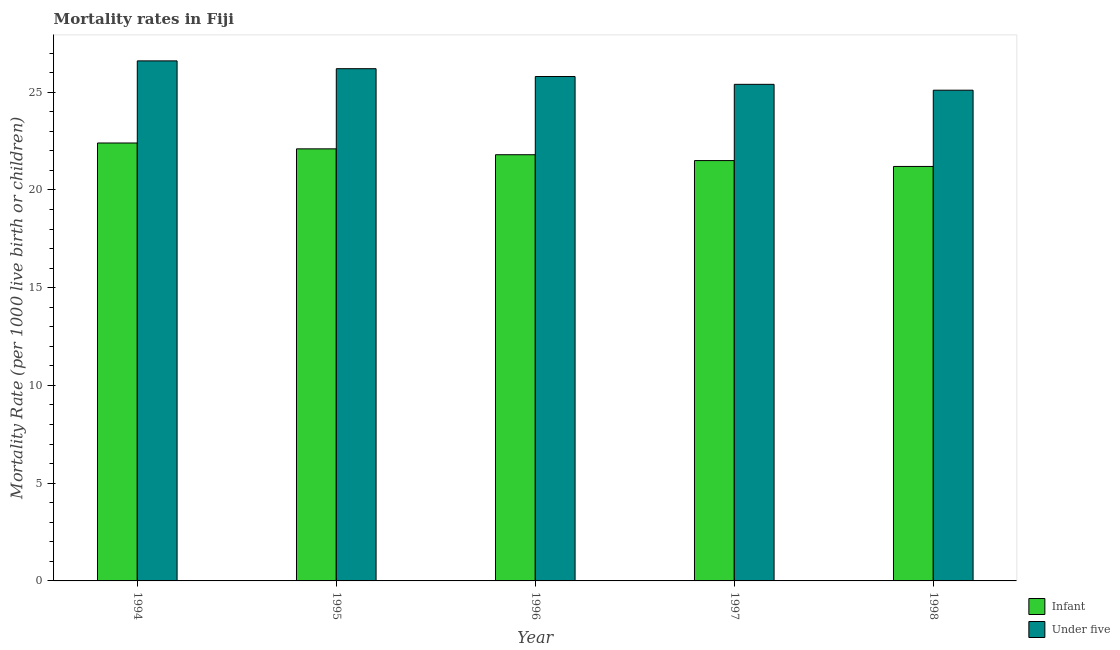How many different coloured bars are there?
Your answer should be compact. 2. Are the number of bars per tick equal to the number of legend labels?
Provide a short and direct response. Yes. How many bars are there on the 3rd tick from the right?
Offer a terse response. 2. In how many cases, is the number of bars for a given year not equal to the number of legend labels?
Your answer should be compact. 0. Across all years, what is the maximum infant mortality rate?
Ensure brevity in your answer.  22.4. Across all years, what is the minimum under-5 mortality rate?
Keep it short and to the point. 25.1. What is the total under-5 mortality rate in the graph?
Provide a short and direct response. 129.1. What is the difference between the infant mortality rate in 1996 and that in 1997?
Your response must be concise. 0.3. What is the difference between the infant mortality rate in 1996 and the under-5 mortality rate in 1997?
Your answer should be very brief. 0.3. What is the average infant mortality rate per year?
Your response must be concise. 21.8. In the year 1994, what is the difference between the under-5 mortality rate and infant mortality rate?
Your answer should be very brief. 0. What is the ratio of the under-5 mortality rate in 1994 to that in 1996?
Offer a terse response. 1.03. Is the under-5 mortality rate in 1994 less than that in 1995?
Give a very brief answer. No. What is the difference between the highest and the second highest under-5 mortality rate?
Your answer should be compact. 0.4. Is the sum of the under-5 mortality rate in 1994 and 1995 greater than the maximum infant mortality rate across all years?
Provide a succinct answer. Yes. What does the 2nd bar from the left in 1995 represents?
Offer a terse response. Under five. What does the 1st bar from the right in 1995 represents?
Give a very brief answer. Under five. How many bars are there?
Ensure brevity in your answer.  10. What is the difference between two consecutive major ticks on the Y-axis?
Ensure brevity in your answer.  5. Where does the legend appear in the graph?
Your answer should be compact. Bottom right. How are the legend labels stacked?
Give a very brief answer. Vertical. What is the title of the graph?
Your answer should be compact. Mortality rates in Fiji. Does "Resident" appear as one of the legend labels in the graph?
Your response must be concise. No. What is the label or title of the X-axis?
Keep it short and to the point. Year. What is the label or title of the Y-axis?
Make the answer very short. Mortality Rate (per 1000 live birth or children). What is the Mortality Rate (per 1000 live birth or children) in Infant in 1994?
Your answer should be very brief. 22.4. What is the Mortality Rate (per 1000 live birth or children) in Under five in 1994?
Your answer should be compact. 26.6. What is the Mortality Rate (per 1000 live birth or children) of Infant in 1995?
Your response must be concise. 22.1. What is the Mortality Rate (per 1000 live birth or children) of Under five in 1995?
Your response must be concise. 26.2. What is the Mortality Rate (per 1000 live birth or children) in Infant in 1996?
Ensure brevity in your answer.  21.8. What is the Mortality Rate (per 1000 live birth or children) of Under five in 1996?
Make the answer very short. 25.8. What is the Mortality Rate (per 1000 live birth or children) of Under five in 1997?
Offer a terse response. 25.4. What is the Mortality Rate (per 1000 live birth or children) in Infant in 1998?
Your answer should be compact. 21.2. What is the Mortality Rate (per 1000 live birth or children) in Under five in 1998?
Your answer should be very brief. 25.1. Across all years, what is the maximum Mortality Rate (per 1000 live birth or children) in Infant?
Provide a succinct answer. 22.4. Across all years, what is the maximum Mortality Rate (per 1000 live birth or children) of Under five?
Provide a short and direct response. 26.6. Across all years, what is the minimum Mortality Rate (per 1000 live birth or children) in Infant?
Provide a short and direct response. 21.2. Across all years, what is the minimum Mortality Rate (per 1000 live birth or children) of Under five?
Make the answer very short. 25.1. What is the total Mortality Rate (per 1000 live birth or children) in Infant in the graph?
Your answer should be compact. 109. What is the total Mortality Rate (per 1000 live birth or children) in Under five in the graph?
Offer a very short reply. 129.1. What is the difference between the Mortality Rate (per 1000 live birth or children) of Infant in 1994 and that in 1995?
Provide a short and direct response. 0.3. What is the difference between the Mortality Rate (per 1000 live birth or children) in Infant in 1994 and that in 1996?
Provide a succinct answer. 0.6. What is the difference between the Mortality Rate (per 1000 live birth or children) in Infant in 1996 and that in 1997?
Offer a very short reply. 0.3. What is the difference between the Mortality Rate (per 1000 live birth or children) of Under five in 1996 and that in 1998?
Ensure brevity in your answer.  0.7. What is the difference between the Mortality Rate (per 1000 live birth or children) in Infant in 1997 and that in 1998?
Offer a terse response. 0.3. What is the difference between the Mortality Rate (per 1000 live birth or children) in Infant in 1994 and the Mortality Rate (per 1000 live birth or children) in Under five in 1995?
Your response must be concise. -3.8. What is the difference between the Mortality Rate (per 1000 live birth or children) in Infant in 1994 and the Mortality Rate (per 1000 live birth or children) in Under five in 1998?
Make the answer very short. -2.7. What is the difference between the Mortality Rate (per 1000 live birth or children) in Infant in 1995 and the Mortality Rate (per 1000 live birth or children) in Under five in 1998?
Keep it short and to the point. -3. What is the difference between the Mortality Rate (per 1000 live birth or children) of Infant in 1996 and the Mortality Rate (per 1000 live birth or children) of Under five in 1998?
Make the answer very short. -3.3. What is the difference between the Mortality Rate (per 1000 live birth or children) in Infant in 1997 and the Mortality Rate (per 1000 live birth or children) in Under five in 1998?
Provide a succinct answer. -3.6. What is the average Mortality Rate (per 1000 live birth or children) of Infant per year?
Offer a very short reply. 21.8. What is the average Mortality Rate (per 1000 live birth or children) of Under five per year?
Give a very brief answer. 25.82. In the year 1994, what is the difference between the Mortality Rate (per 1000 live birth or children) in Infant and Mortality Rate (per 1000 live birth or children) in Under five?
Your response must be concise. -4.2. In the year 1995, what is the difference between the Mortality Rate (per 1000 live birth or children) in Infant and Mortality Rate (per 1000 live birth or children) in Under five?
Offer a very short reply. -4.1. In the year 1996, what is the difference between the Mortality Rate (per 1000 live birth or children) in Infant and Mortality Rate (per 1000 live birth or children) in Under five?
Make the answer very short. -4. What is the ratio of the Mortality Rate (per 1000 live birth or children) of Infant in 1994 to that in 1995?
Keep it short and to the point. 1.01. What is the ratio of the Mortality Rate (per 1000 live birth or children) of Under five in 1994 to that in 1995?
Offer a very short reply. 1.02. What is the ratio of the Mortality Rate (per 1000 live birth or children) of Infant in 1994 to that in 1996?
Offer a very short reply. 1.03. What is the ratio of the Mortality Rate (per 1000 live birth or children) in Under five in 1994 to that in 1996?
Your answer should be compact. 1.03. What is the ratio of the Mortality Rate (per 1000 live birth or children) in Infant in 1994 to that in 1997?
Provide a succinct answer. 1.04. What is the ratio of the Mortality Rate (per 1000 live birth or children) in Under five in 1994 to that in 1997?
Keep it short and to the point. 1.05. What is the ratio of the Mortality Rate (per 1000 live birth or children) of Infant in 1994 to that in 1998?
Make the answer very short. 1.06. What is the ratio of the Mortality Rate (per 1000 live birth or children) of Under five in 1994 to that in 1998?
Your answer should be compact. 1.06. What is the ratio of the Mortality Rate (per 1000 live birth or children) in Infant in 1995 to that in 1996?
Ensure brevity in your answer.  1.01. What is the ratio of the Mortality Rate (per 1000 live birth or children) in Under five in 1995 to that in 1996?
Offer a very short reply. 1.02. What is the ratio of the Mortality Rate (per 1000 live birth or children) in Infant in 1995 to that in 1997?
Provide a succinct answer. 1.03. What is the ratio of the Mortality Rate (per 1000 live birth or children) in Under five in 1995 to that in 1997?
Keep it short and to the point. 1.03. What is the ratio of the Mortality Rate (per 1000 live birth or children) in Infant in 1995 to that in 1998?
Provide a short and direct response. 1.04. What is the ratio of the Mortality Rate (per 1000 live birth or children) of Under five in 1995 to that in 1998?
Provide a succinct answer. 1.04. What is the ratio of the Mortality Rate (per 1000 live birth or children) in Under five in 1996 to that in 1997?
Your answer should be very brief. 1.02. What is the ratio of the Mortality Rate (per 1000 live birth or children) of Infant in 1996 to that in 1998?
Your response must be concise. 1.03. What is the ratio of the Mortality Rate (per 1000 live birth or children) of Under five in 1996 to that in 1998?
Offer a very short reply. 1.03. What is the ratio of the Mortality Rate (per 1000 live birth or children) of Infant in 1997 to that in 1998?
Make the answer very short. 1.01. What is the difference between the highest and the second highest Mortality Rate (per 1000 live birth or children) in Infant?
Make the answer very short. 0.3. What is the difference between the highest and the lowest Mortality Rate (per 1000 live birth or children) in Infant?
Your answer should be compact. 1.2. 